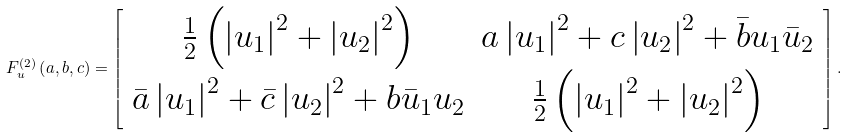Convert formula to latex. <formula><loc_0><loc_0><loc_500><loc_500>F ^ { \left ( 2 \right ) } _ { u } \left ( a , b , c \right ) = \left [ \begin{array} { c c } \frac { 1 } { 2 } \left ( \left | u _ { 1 } \right | ^ { 2 } + \left | u _ { 2 } \right | ^ { 2 } \right ) & a \left | u _ { 1 } \right | ^ { 2 } + c \left | u _ { 2 } \right | ^ { 2 } + \bar { b } u _ { 1 } \bar { u } _ { 2 } \\ \bar { a } \left | u _ { 1 } \right | ^ { 2 } + \bar { c } \left | u _ { 2 } \right | ^ { 2 } + b \bar { u } _ { 1 } u _ { 2 } & \frac { 1 } { 2 } \left ( \left | u _ { 1 } \right | ^ { 2 } + \left | u _ { 2 } \right | ^ { 2 } \right ) \\ \end{array} \right ] .</formula> 